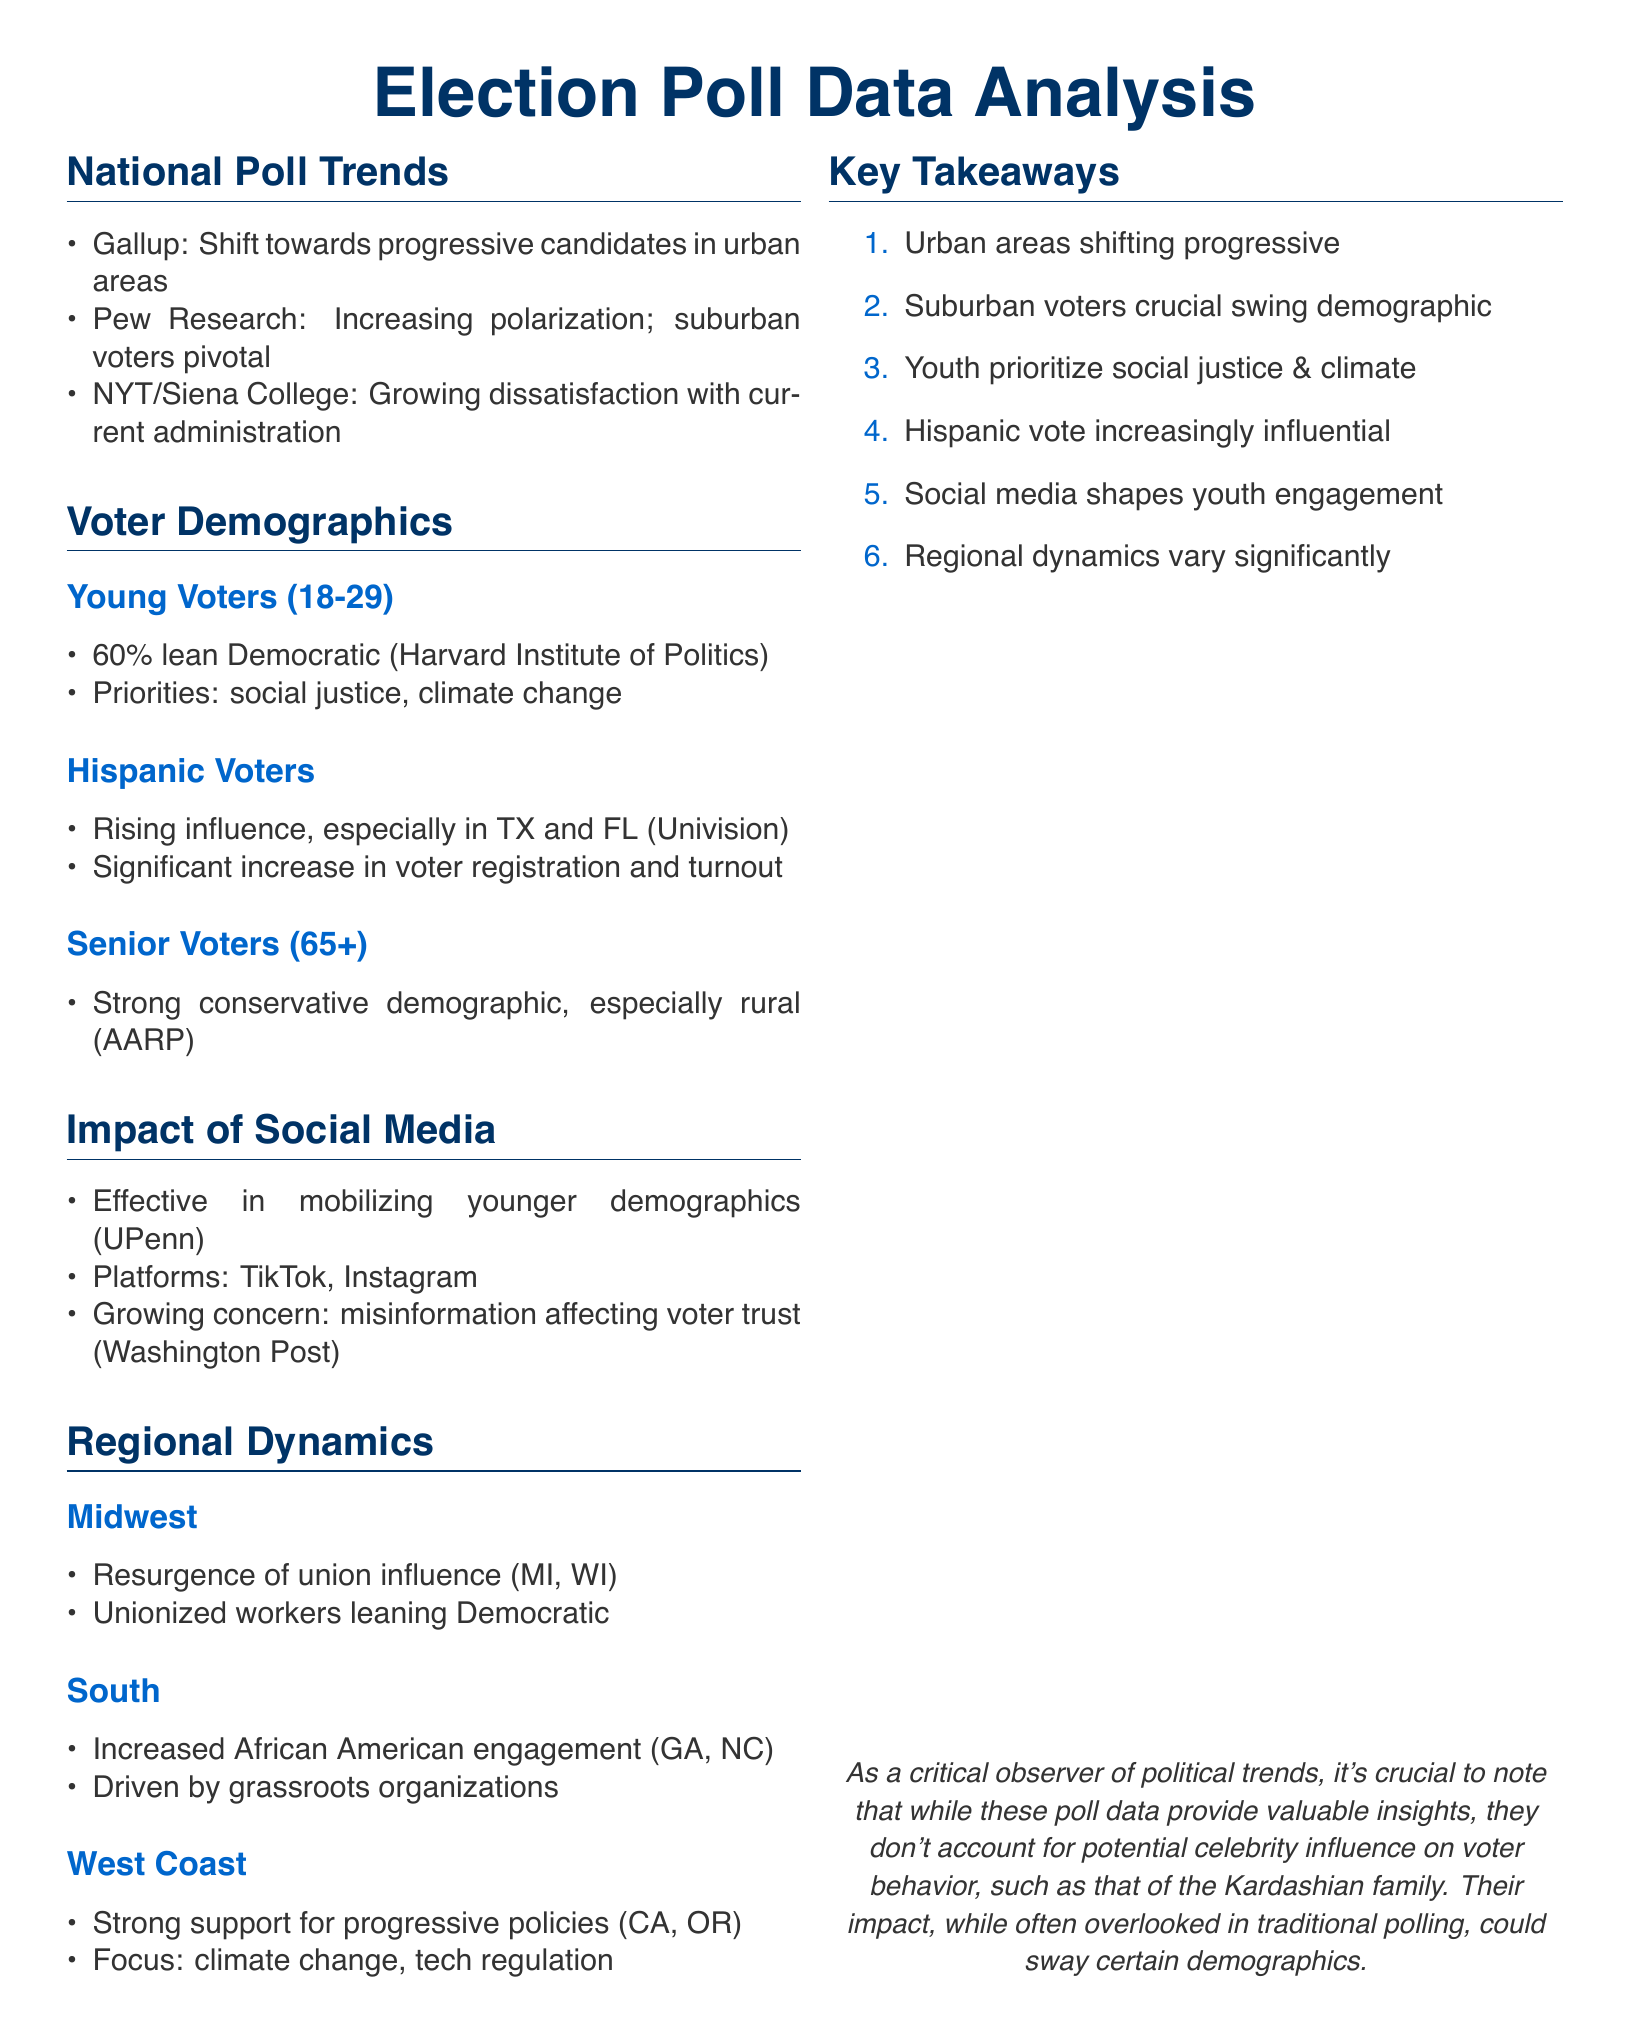what is the percentage of young voters that lean Democratic? The document states that 60% of young voters lean Democratic according to the Harvard Institute of Politics.
Answer: 60% which demographic is increasingly influential in Texas and Florida? The document indicates that Hispanic voters are rising in influence in Texas and Florida according to Univision.
Answer: Hispanic voters what are the two main priorities of young voters? The document lists social justice and climate change as the main priorities for young voters.
Answer: social justice, climate change which platforms are noted for mobilizing younger demographics? The document specifies TikTok and Instagram as effective platforms for mobilizing younger voters.
Answer: TikTok, Instagram which region is experiencing a resurgence of union influence? The document mentions the Midwest, particularly Michigan and Wisconsin, as experiencing a resurgence of union influence.
Answer: Midwest what is a key takeaway about suburban voters? The document states that suburban voters are a crucial swing demographic in upcoming elections.
Answer: crucial swing demographic what is a growing concern related to social media's impact on voters? The document highlights misinformation as a growing concern affecting voter trust.
Answer: misinformation what is the primary demographic that strongly supports conservative values? The document notes that senior voters, particularly those aged 65 and above, strongly align with conservative values.
Answer: Senior voters which grassroots organizations have driven increased engagement in the South? The document cites grassroots organizations as the driver for increased African American engagement in states like Georgia and North Carolina.
Answer: grassroots organizations 